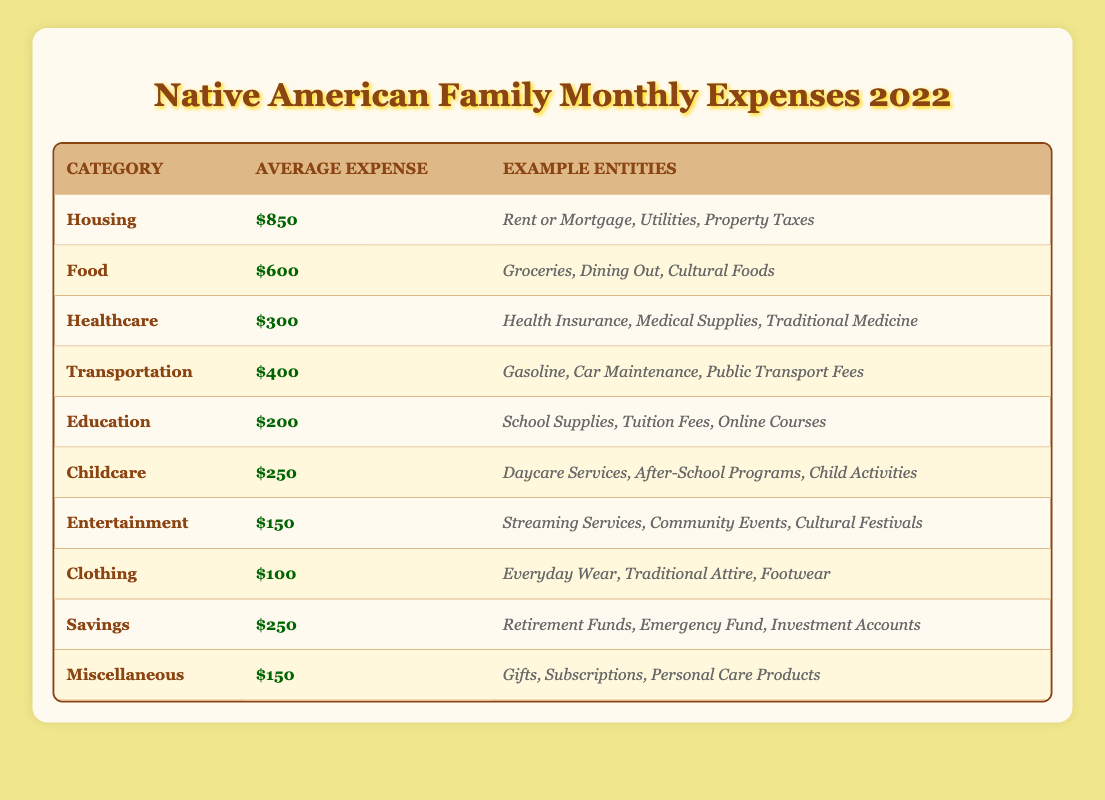What is the average expense for Housing? The table lists the average expense for Housing as $850. This value can be found directly under the "Average Expense" column for the "Housing" category.
Answer: $850 Which category has the highest expense? By examining the "Average Expense" column, Housing shows the highest value at $850, making it the category with the highest expense.
Answer: Housing What is the total average expense of Food and Childcare? To find the total average expense of Food and Childcare, we add the average expenses from both categories: Food ($600) + Childcare ($250) results in $850.
Answer: $850 Are the average expenses for Healthcare and Education both less than $400? The average expense for Healthcare is $300 and for Education is $200. Since both values are less than $400, the answer is yes.
Answer: Yes What is the difference between the average expenses of Transportation and Entertainment? To find the difference, subtract the average expense of Entertainment ($150) from Transportation ($400): $400 - $150 = $250. This tells us how much more is spent on Transportation compared to Entertainment.
Answer: $250 What percentage of the total monthly expenses does Clothing represent? First, we need to determine the total expenses by summing all the average expenses: $850 + $600 + $300 + $400 + $200 + $250 + $150 + $100 + $250 + $150 = $2950. The expense for Clothing is $100. To find the percentage: ($100 / $2950) × 100 = approximately 3.39%.
Answer: 3.39% Which categories have an average expense greater than $200? Looking at the averages, the categories with average expenses over $200 are Housing ($850), Food ($600), Healthcare ($300), Transportation ($400), and Childcare ($250). This requires checking each value against $200.
Answer: Housing, Food, Healthcare, Transportation, Childcare Is the average expense for Savings equal to $250? The table lists the average expense for Savings as $250, so this statement is true.
Answer: Yes What are the average expenses for the categories that include healthcare-related apects? Healthcare is the only category listed among the expenses that directly relate to healthcare, with an average expense of $300.
Answer: $300 